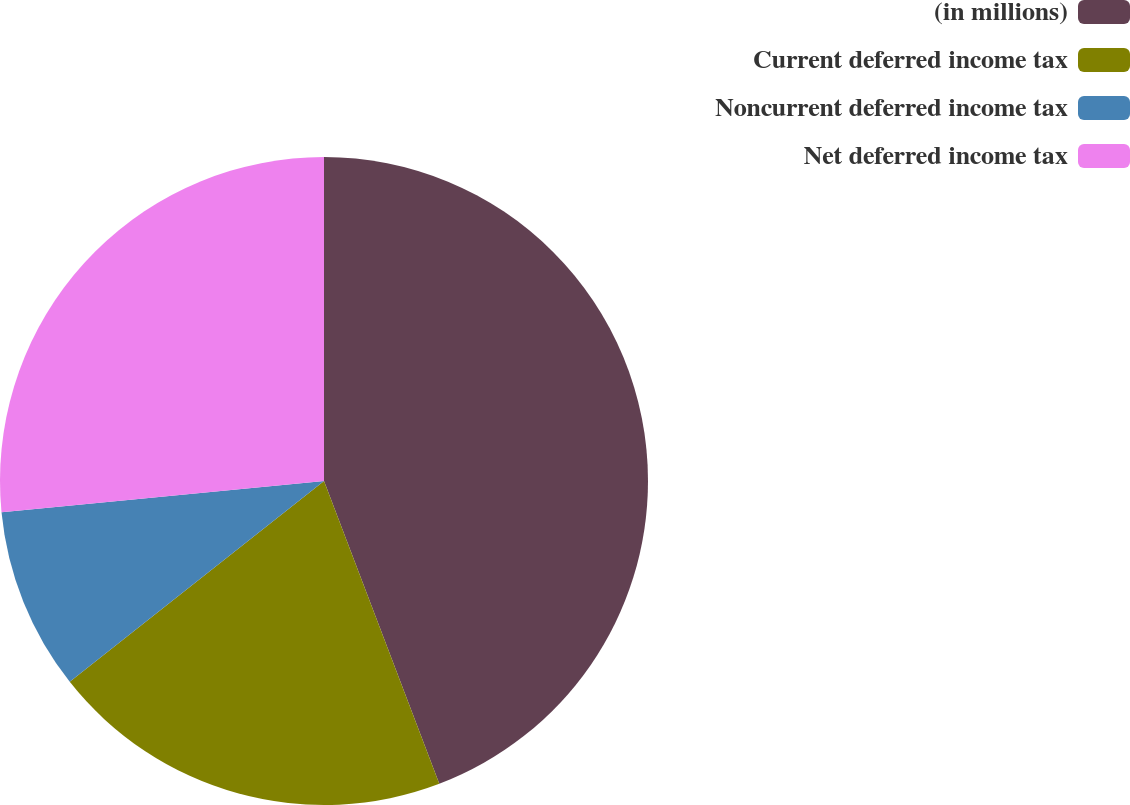Convert chart. <chart><loc_0><loc_0><loc_500><loc_500><pie_chart><fcel>(in millions)<fcel>Current deferred income tax<fcel>Noncurrent deferred income tax<fcel>Net deferred income tax<nl><fcel>44.21%<fcel>20.15%<fcel>9.1%<fcel>26.54%<nl></chart> 